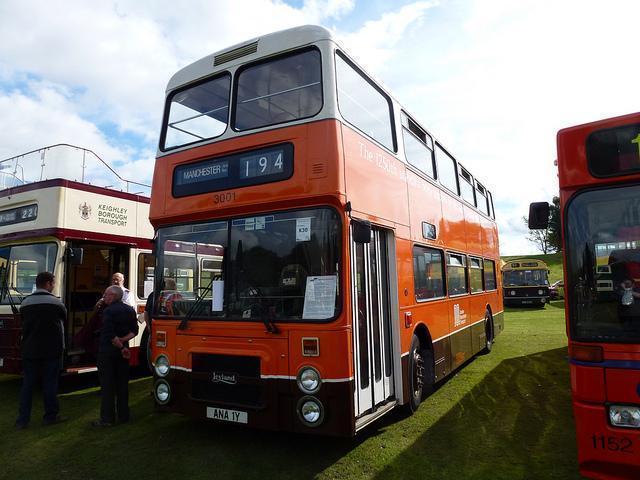What number is on the bus in the middle?
Answer the question by selecting the correct answer among the 4 following choices.
Options: 888, 202, 194, 456. 194. 